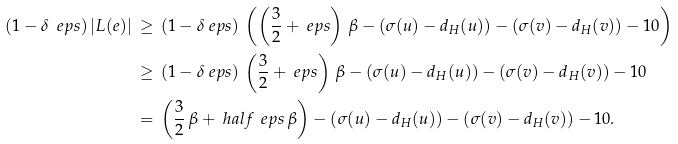Convert formula to latex. <formula><loc_0><loc_0><loc_500><loc_500>( 1 - \delta _ { \ } e p s ) \, | L ( e ) | \, & \geq \, ( 1 - \delta _ { \ } e p s ) \, \left ( \left ( \frac { 3 } { 2 } + \ e p s \right ) \, \beta - ( \sigma ( u ) - d _ { H } ( u ) ) - ( \sigma ( v ) - d _ { H } ( v ) ) - 1 0 \right ) \\ & \geq \, ( 1 - \delta _ { \ } e p s ) \, \left ( \frac { 3 } { 2 } + \ e p s \right ) \, \beta - ( \sigma ( u ) - d _ { H } ( u ) ) - ( \sigma ( v ) - d _ { H } ( v ) ) - 1 0 \\ & = \, \left ( \frac { 3 } { 2 } \, \beta + \ h a l f \, \ e p s \, \beta \right ) - ( \sigma ( u ) - d _ { H } ( u ) ) - ( \sigma ( v ) - d _ { H } ( v ) ) - 1 0 .</formula> 